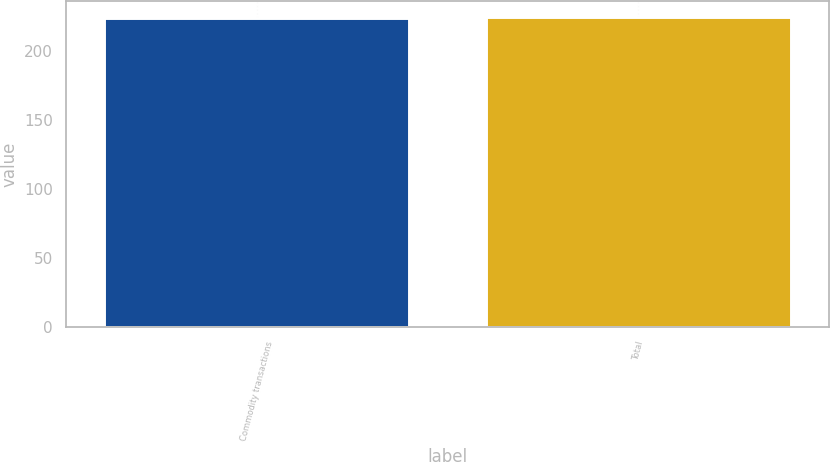Convert chart. <chart><loc_0><loc_0><loc_500><loc_500><bar_chart><fcel>Commodity transactions<fcel>Total<nl><fcel>224<fcel>225<nl></chart> 